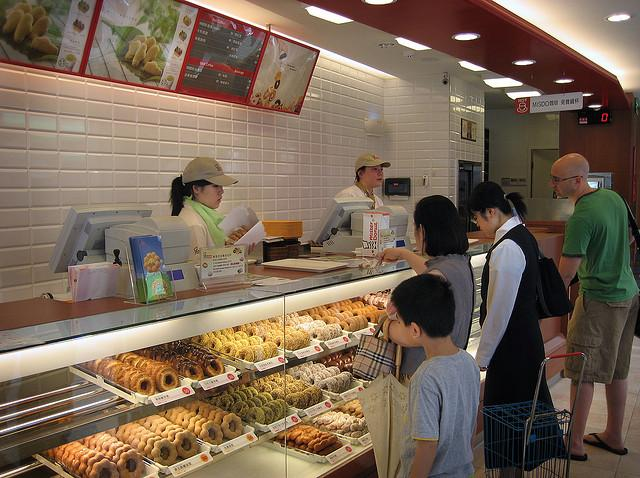In which liquid were most of the shown treats boiled?

Choices:
A) dishwater
B) oil
C) petrol
D) water oil 